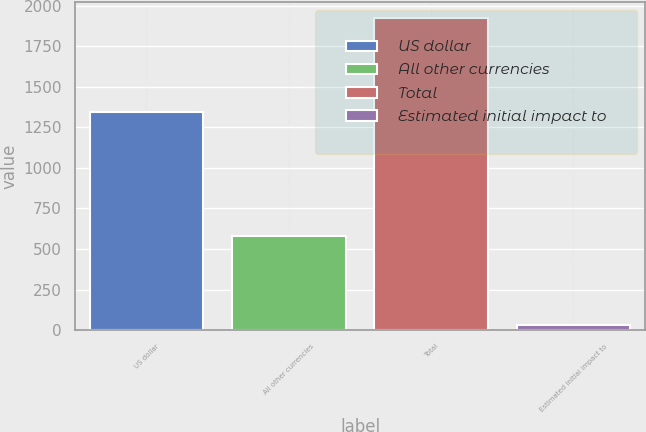<chart> <loc_0><loc_0><loc_500><loc_500><bar_chart><fcel>US dollar<fcel>All other currencies<fcel>Total<fcel>Estimated initial impact to<nl><fcel>1346<fcel>580<fcel>1926<fcel>34<nl></chart> 